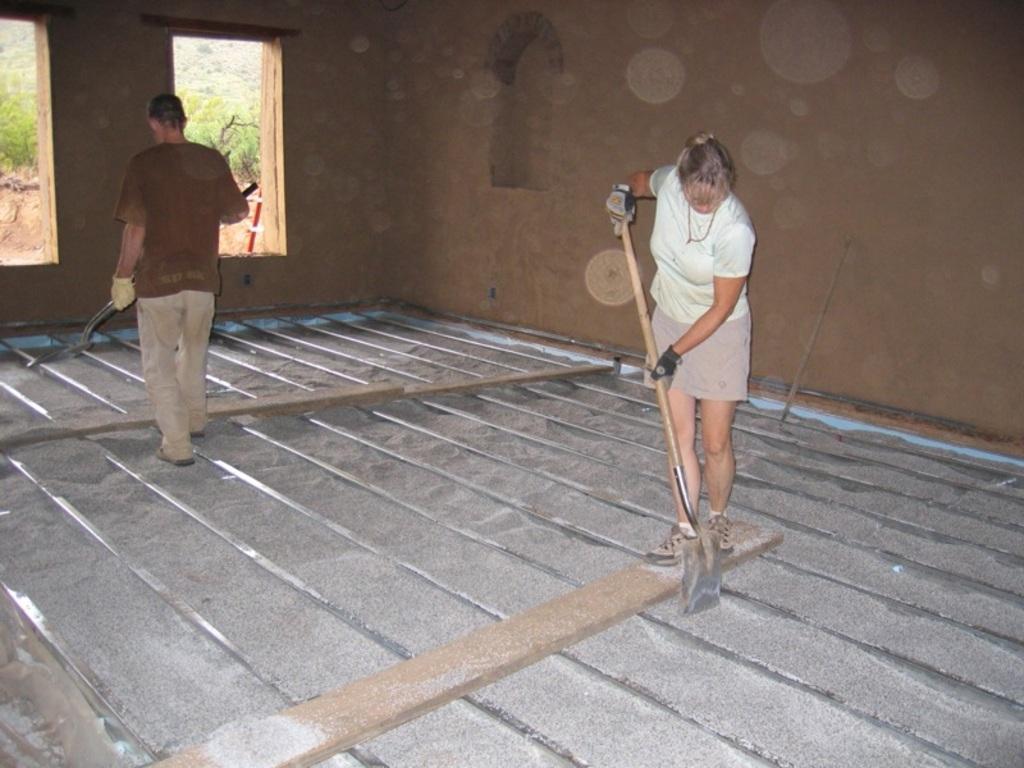Describe this image in one or two sentences. In this picture, there is a woman towards the right and a man towards the left. Both of them are holding tools. Woman is wearing a white t shirt and man is wearing a brown t shirt. At the bottom there are rods. with some cement sand. In the background, there is a wall and trees. 